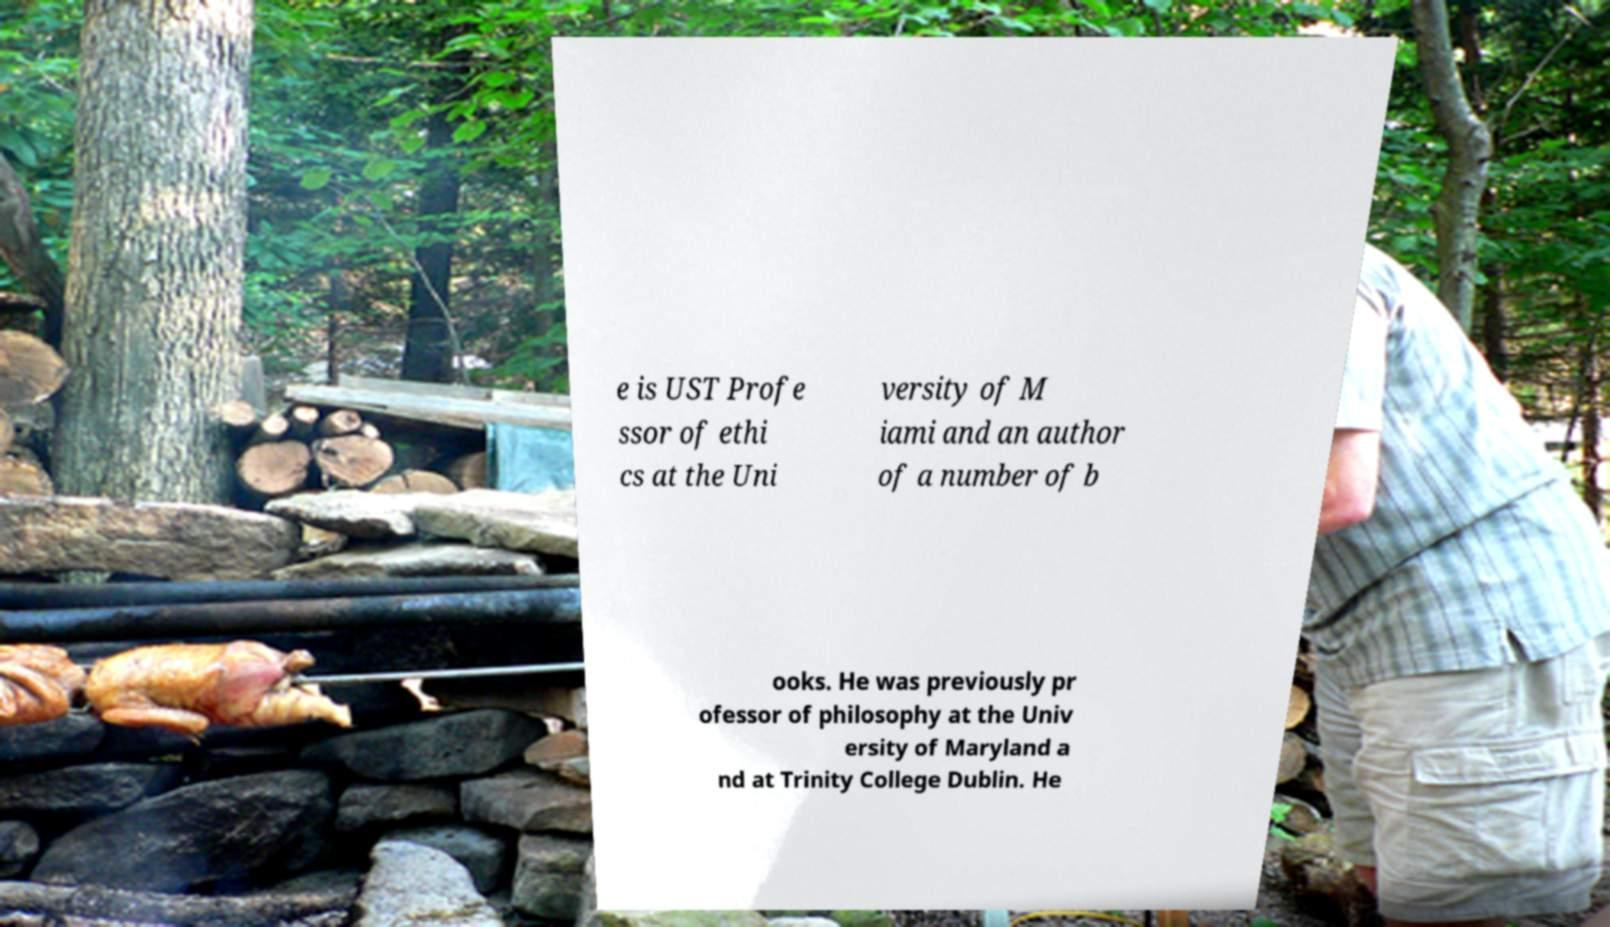There's text embedded in this image that I need extracted. Can you transcribe it verbatim? e is UST Profe ssor of ethi cs at the Uni versity of M iami and an author of a number of b ooks. He was previously pr ofessor of philosophy at the Univ ersity of Maryland a nd at Trinity College Dublin. He 